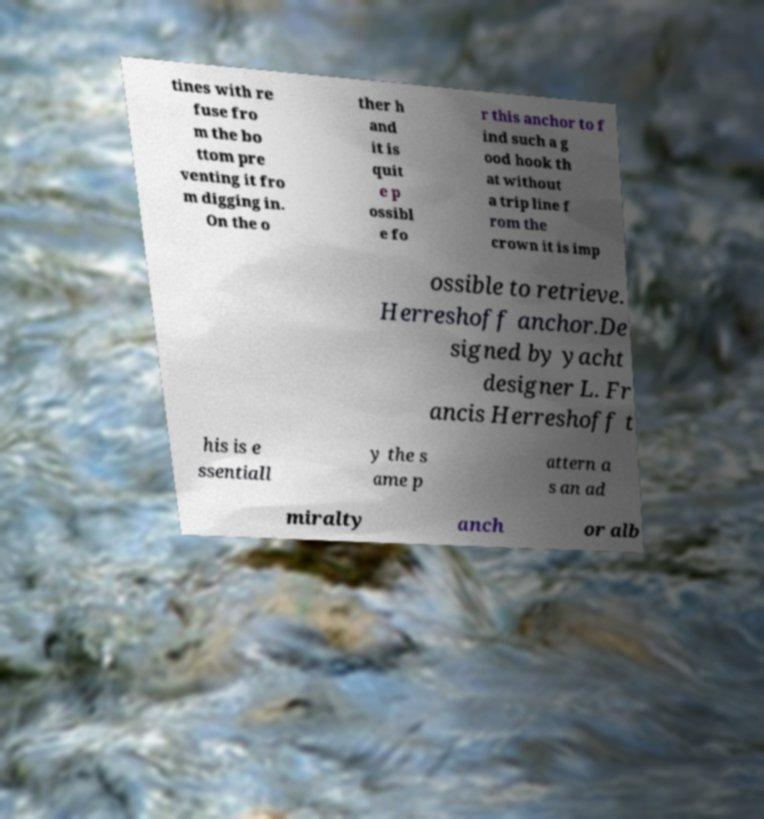Can you read and provide the text displayed in the image?This photo seems to have some interesting text. Can you extract and type it out for me? tines with re fuse fro m the bo ttom pre venting it fro m digging in. On the o ther h and it is quit e p ossibl e fo r this anchor to f ind such a g ood hook th at without a trip line f rom the crown it is imp ossible to retrieve. Herreshoff anchor.De signed by yacht designer L. Fr ancis Herreshoff t his is e ssentiall y the s ame p attern a s an ad miralty anch or alb 